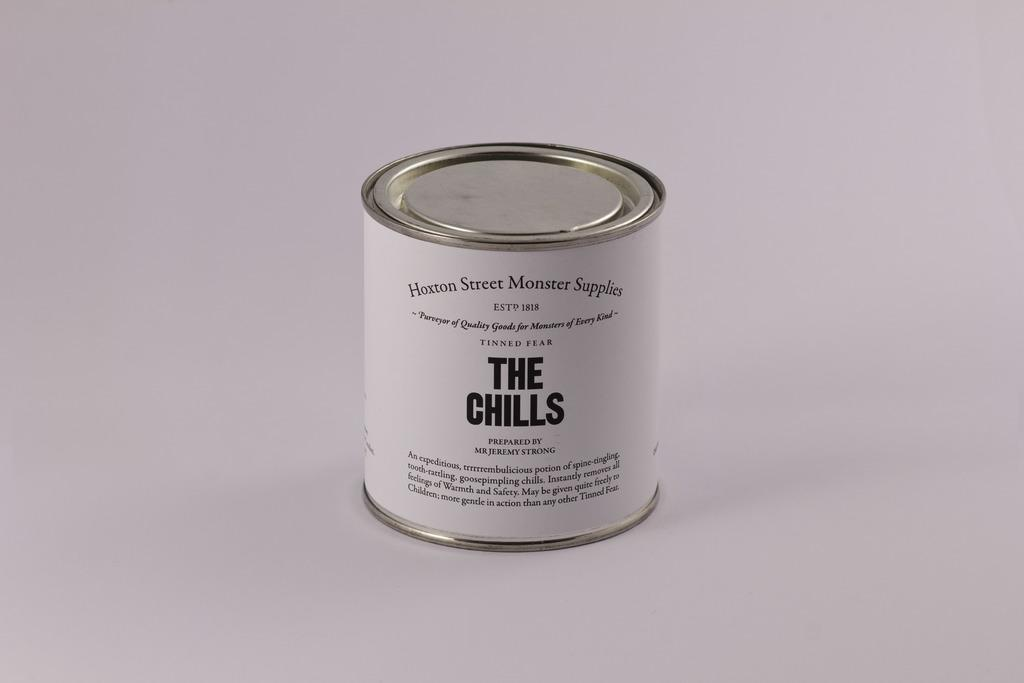<image>
Render a clear and concise summary of the photo. A can of The Chills by Hoxton Street Monster Supply sits on a table. 